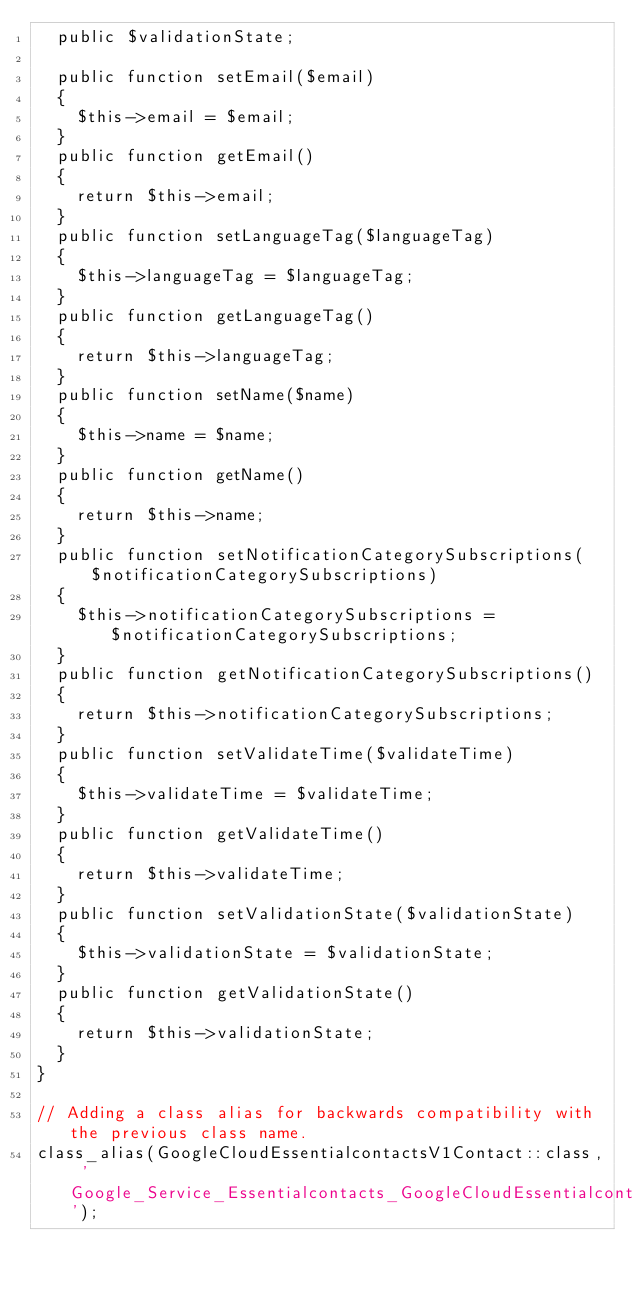Convert code to text. <code><loc_0><loc_0><loc_500><loc_500><_PHP_>  public $validationState;

  public function setEmail($email)
  {
    $this->email = $email;
  }
  public function getEmail()
  {
    return $this->email;
  }
  public function setLanguageTag($languageTag)
  {
    $this->languageTag = $languageTag;
  }
  public function getLanguageTag()
  {
    return $this->languageTag;
  }
  public function setName($name)
  {
    $this->name = $name;
  }
  public function getName()
  {
    return $this->name;
  }
  public function setNotificationCategorySubscriptions($notificationCategorySubscriptions)
  {
    $this->notificationCategorySubscriptions = $notificationCategorySubscriptions;
  }
  public function getNotificationCategorySubscriptions()
  {
    return $this->notificationCategorySubscriptions;
  }
  public function setValidateTime($validateTime)
  {
    $this->validateTime = $validateTime;
  }
  public function getValidateTime()
  {
    return $this->validateTime;
  }
  public function setValidationState($validationState)
  {
    $this->validationState = $validationState;
  }
  public function getValidationState()
  {
    return $this->validationState;
  }
}

// Adding a class alias for backwards compatibility with the previous class name.
class_alias(GoogleCloudEssentialcontactsV1Contact::class, 'Google_Service_Essentialcontacts_GoogleCloudEssentialcontactsV1Contact');
</code> 